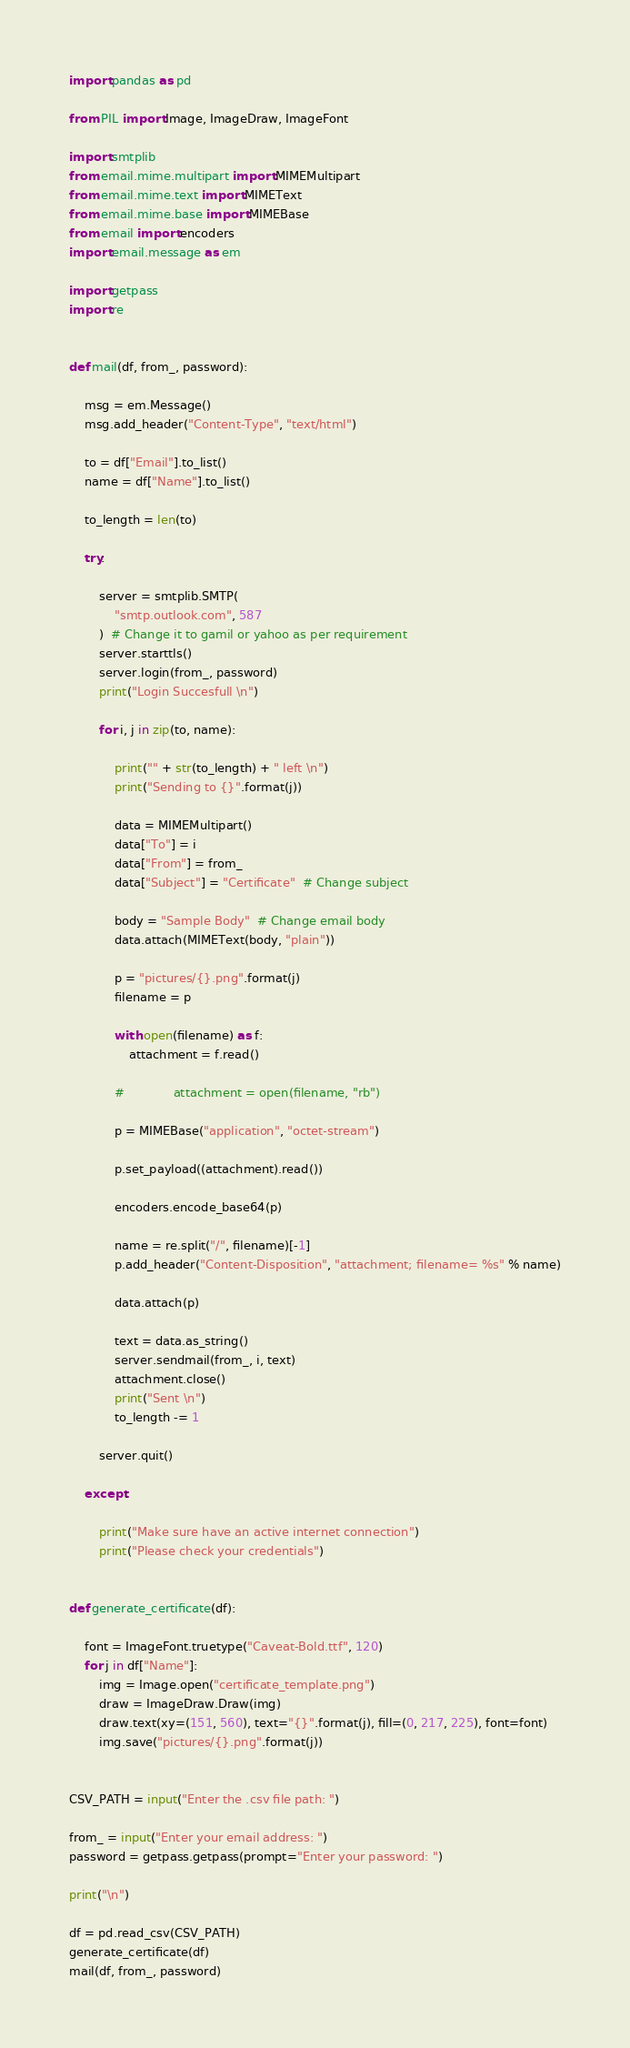<code> <loc_0><loc_0><loc_500><loc_500><_Python_>import pandas as pd

from PIL import Image, ImageDraw, ImageFont

import smtplib
from email.mime.multipart import MIMEMultipart
from email.mime.text import MIMEText
from email.mime.base import MIMEBase
from email import encoders
import email.message as em

import getpass
import re


def mail(df, from_, password):

    msg = em.Message()
    msg.add_header("Content-Type", "text/html")

    to = df["Email"].to_list()
    name = df["Name"].to_list()

    to_length = len(to)

    try:

        server = smtplib.SMTP(
            "smtp.outlook.com", 587
        )  # Change it to gamil or yahoo as per requirement
        server.starttls()
        server.login(from_, password)
        print("Login Succesfull \n")

        for i, j in zip(to, name):

            print("" + str(to_length) + " left \n")
            print("Sending to {}".format(j))

            data = MIMEMultipart()
            data["To"] = i
            data["From"] = from_
            data["Subject"] = "Certificate"  # Change subject

            body = "Sample Body"  # Change email body
            data.attach(MIMEText(body, "plain"))

            p = "pictures/{}.png".format(j)
            filename = p

            with open(filename) as f:
                attachment = f.read()

            #             attachment = open(filename, "rb")

            p = MIMEBase("application", "octet-stream")

            p.set_payload((attachment).read())

            encoders.encode_base64(p)

            name = re.split("/", filename)[-1]
            p.add_header("Content-Disposition", "attachment; filename= %s" % name)

            data.attach(p)

            text = data.as_string()
            server.sendmail(from_, i, text)
            attachment.close()
            print("Sent \n")
            to_length -= 1

        server.quit()

    except:

        print("Make sure have an active internet connection")
        print("Please check your credentials")


def generate_certificate(df):

    font = ImageFont.truetype("Caveat-Bold.ttf", 120)
    for j in df["Name"]:
        img = Image.open("certificate_template.png")
        draw = ImageDraw.Draw(img)
        draw.text(xy=(151, 560), text="{}".format(j), fill=(0, 217, 225), font=font)
        img.save("pictures/{}.png".format(j))


CSV_PATH = input("Enter the .csv file path: ")

from_ = input("Enter your email address: ")
password = getpass.getpass(prompt="Enter your password: ")

print("\n")

df = pd.read_csv(CSV_PATH)
generate_certificate(df)
mail(df, from_, password)
</code> 